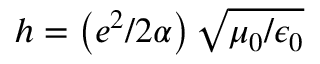<formula> <loc_0><loc_0><loc_500><loc_500>h = \left ( e ^ { 2 } / 2 \alpha \right ) \sqrt { \mu _ { 0 } / \epsilon _ { 0 } }</formula> 